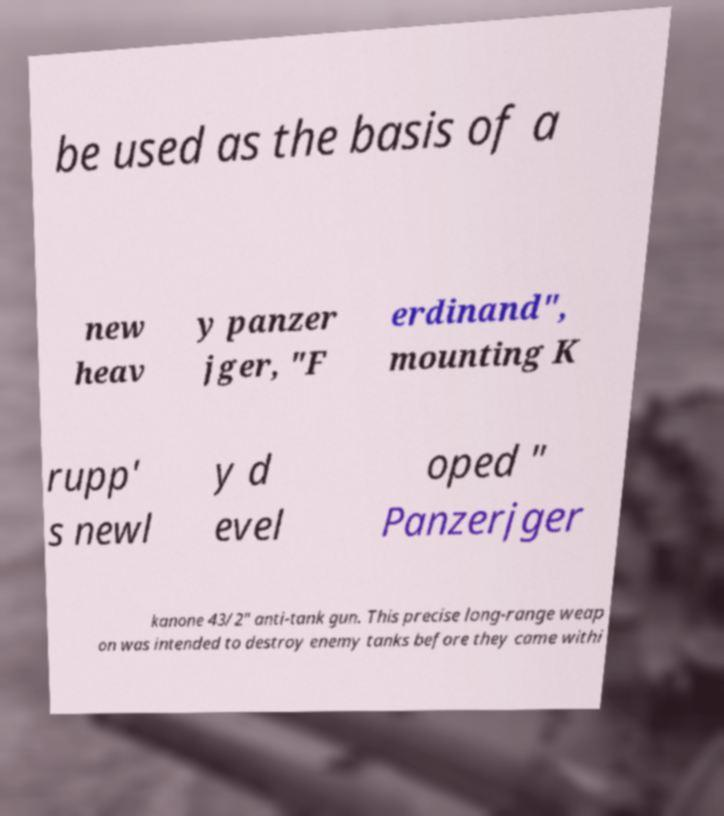Can you accurately transcribe the text from the provided image for me? be used as the basis of a new heav y panzer jger, "F erdinand", mounting K rupp' s newl y d evel oped " Panzerjger kanone 43/2" anti-tank gun. This precise long-range weap on was intended to destroy enemy tanks before they came withi 